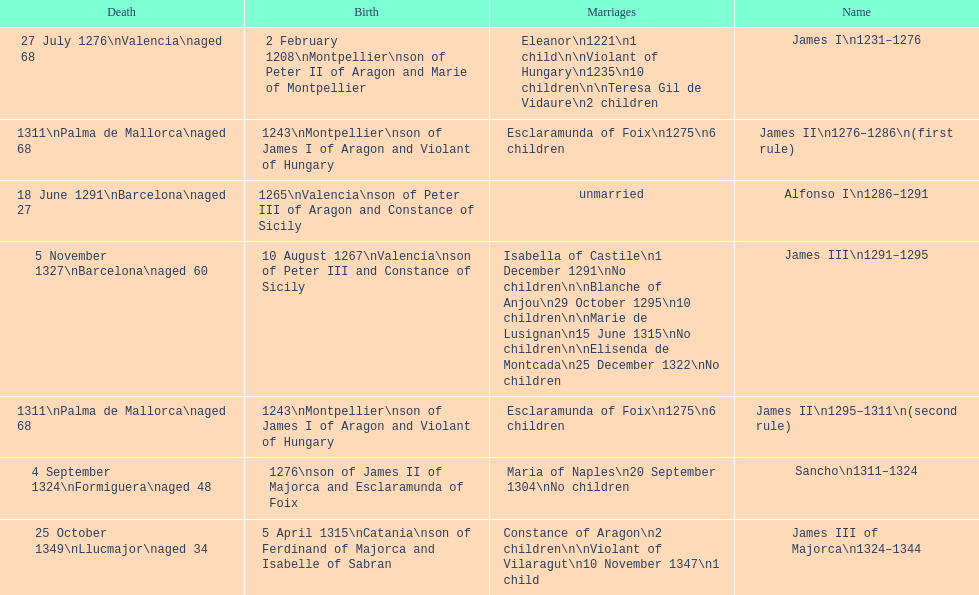How many times did james i get married in total? 3. 